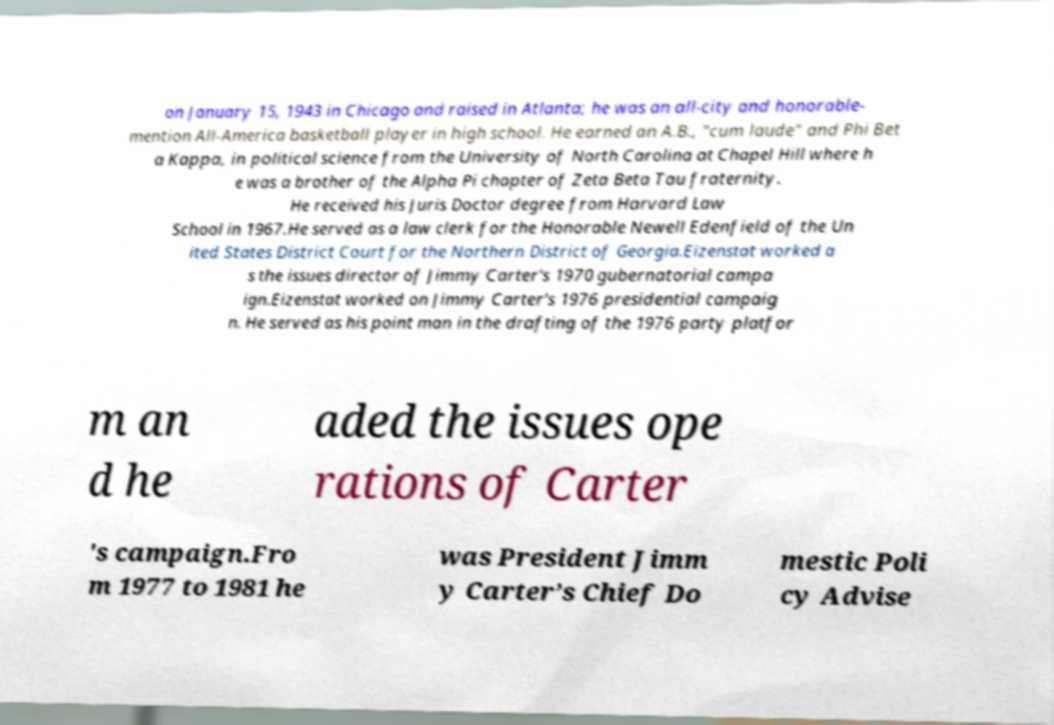Please read and relay the text visible in this image. What does it say? on January 15, 1943 in Chicago and raised in Atlanta; he was an all-city and honorable- mention All-America basketball player in high school. He earned an A.B., "cum laude" and Phi Bet a Kappa, in political science from the University of North Carolina at Chapel Hill where h e was a brother of the Alpha Pi chapter of Zeta Beta Tau fraternity. He received his Juris Doctor degree from Harvard Law School in 1967.He served as a law clerk for the Honorable Newell Edenfield of the Un ited States District Court for the Northern District of Georgia.Eizenstat worked a s the issues director of Jimmy Carter's 1970 gubernatorial campa ign.Eizenstat worked on Jimmy Carter's 1976 presidential campaig n. He served as his point man in the drafting of the 1976 party platfor m an d he aded the issues ope rations of Carter 's campaign.Fro m 1977 to 1981 he was President Jimm y Carter’s Chief Do mestic Poli cy Advise 